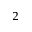Convert formula to latex. <formula><loc_0><loc_0><loc_500><loc_500>^ { 2 }</formula> 